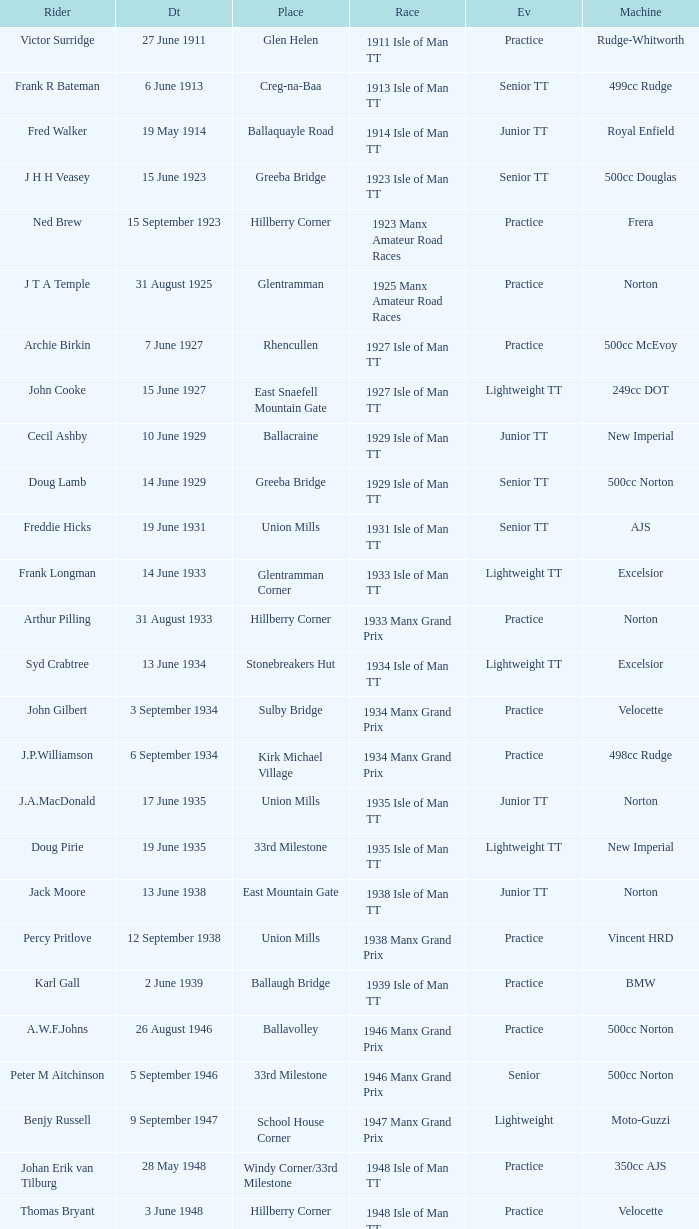What machine did Keith T. Gawler ride? 499cc Norton. 